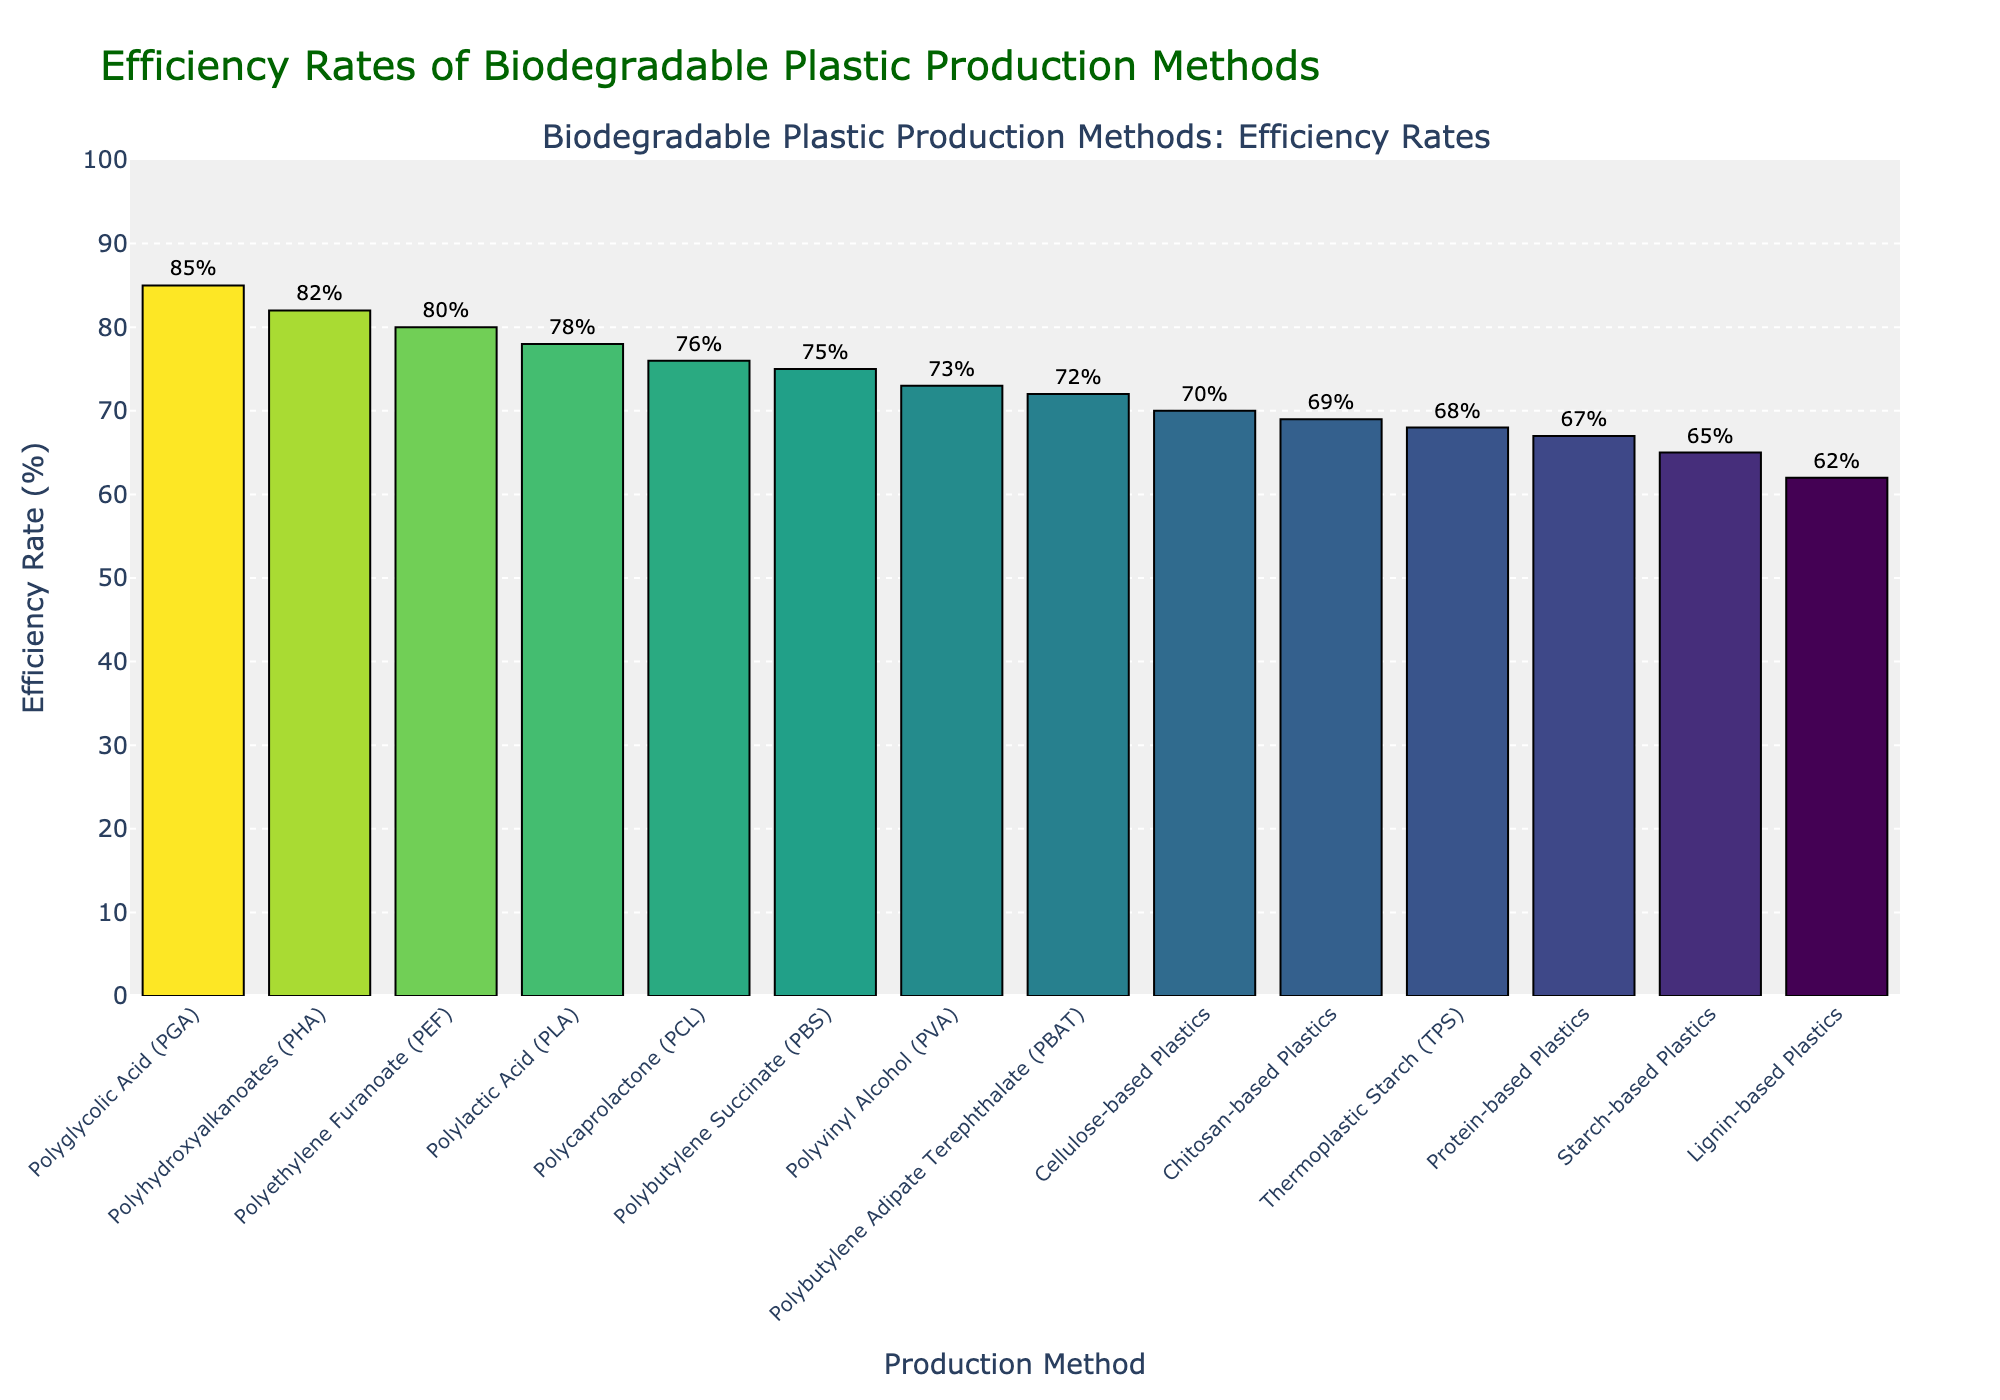What is the highest efficiency rate among the biodegradable plastic production methods? The highest efficiency rate corresponds to the tallest bar in the chart. Polyglycolic Acid (PGA) has the highest efficiency rate of 85%, as indicated at the top left of the chart.
Answer: 85% Which biodegradable plastic has the lowest efficiency rate? The lowest efficiency rate corresponds to the shortest bar in the chart. Lignin-based Plastics have the lowest efficiency rate of 62%.
Answer: Lignin-based Plastics How many biodegradable plastic production methods have an efficiency rate of 75% or higher? Count the bars starting from 75% and above. The methods are Polylactic Acid (PLA), Polyhydroxyalkanoates (PHA), Polybutylene Succinate (PBS), Polyethylene Furanoate (PEF), Polycaprolactone (PCL), Polyglycolic Acid (PGA), and Polyvinyl Alcohol (PVA). There are seven methods.
Answer: 7 What is the difference in efficiency rate between Polyhydroxyalkanoates (PHA) and Starch-based Plastics? Find the efficiency rates of each method and subtract them. PHA is 82% and Starch-based Plastics is 65%. So, the difference is 82% - 65% = 17%.
Answer: 17% Which biodegradable plastic production method has an efficiency rate closest to the average efficiency rate of all methods? Calculate the average efficiency rate: (78 + 82 + 65 + 70 + 75 + 72 + 80 + 68 + 76 + 85 + 73 + 62 + 69 + 67) / 14 = 73.14%. The method Polyvinyl Alcohol (PVA) has an efficiency rate of 73%, which is closest to 73.14%.
Answer: Polyvinyl Alcohol (PVA) Are there more methods with an efficiency rate above or below 70%? Count the number of bars above and below 70%. Above: Polylactic Acid (78%), Polyhydroxyalkanoates (82%), Polybutylene Succinate (75%), Polybutylene Adipate Terephthalate (72%), Polyethylene Furanoate (80%), Thermoplastic Starch (68%), Polycaprolactone (76%), Polyglycolic Acid (85%), Polyvinyl Alcohol (73%), Chitosan-based Plastics (69%), Protein-based Plastics (67%). Below: Starch-based Plastics (65%) and Lignin-based Plastics (62%). More methods have an efficiency rate above 70%.
Answer: Above 70% Which two biodegradable plastic production methods show the least difference in their efficiency rates? Compare the bars to identify the smallest height difference. Polyvinyl Alcohol (PVA) (73%) and Polybutylene Adipate Terephthalate (PBAT) (72%) have the least difference, which is 1%.
Answer: Polyvinyl Alcohol (PVA) and Polybutylene Adipate Terephthalate (PBAT) What is the combined efficiency rate of Polycaprolactone (PCL) and Polyglycolic Acid (PGA)? Add the efficiency rates of PCL and PGA. PCL is 76% and PGA is 85%. So, the combined efficiency rate is 76% + 85% = 161%.
Answer: 161% Which biodegradable plastic production methods have efficiency rates within the range of 65% to 75% inclusive? Identify the bars within the specified range. Starch-based Plastics (65%), Cellulose-based Plastics (70%), Polybutylene Succinate (PBS) (75%), Polybutylene Adipate Terephthalate (PBAT) (72%), Polyvinyl Alcohol (PVA) (73%), Thermoplastic Starch (TPS) (68%), Chitosan-based Plastics (69%), and Protein-based Plastics (67%) are within the range.
Answer: 8 methods Between Polylactic Acid (PLA) and Thermoplastic Starch (TPS), which one has a higher efficiency rate and by how much? Compare the efficiency rates of PLA and TPS. PLA is 78% and TPS is 68%. The difference is 78% - 68% = 10%.
Answer: Polylactic Acid (PLA) by 10% 